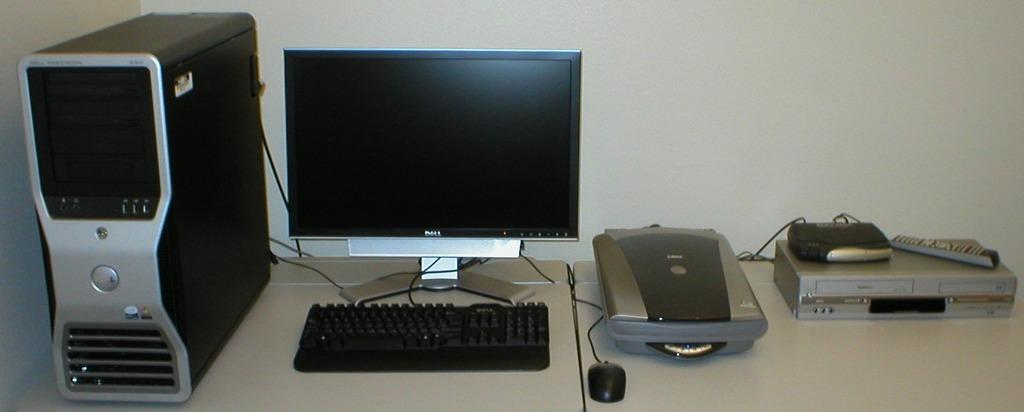What is the main electronic device in the image? There is a CPU in the image. What is the primary output device in the image? There is a monitor in the image. What is the primary input device in the image? There is a keyboard in the image. What is the secondary input device in the image? There is a mouse in the image. What is the additional device in the image? There is a remote in the image. How many additional machines are present in the image? There are additional machines in the image, but the exact number is not specified. What type of word can be seen flying in the air in the image? There is no word or any flying object present in the image. What type of test can be seen being conducted in the image? There is no test or any activity related to testing present in the image. 